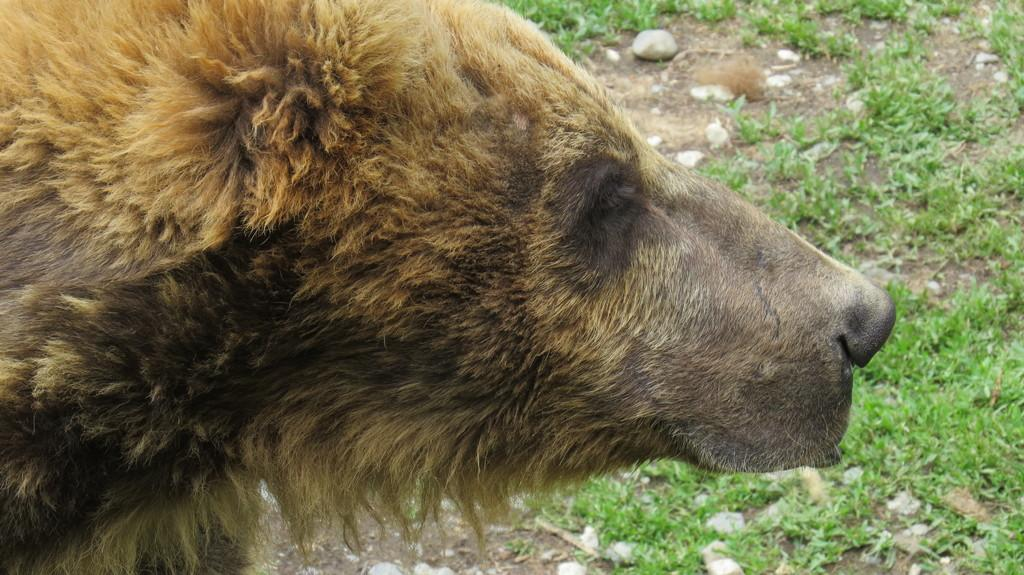What type of living creature can be seen in the picture? There is an animal in the picture. What can be seen beneath the animal's feet? The ground is visible in the picture. What type of vegetation is present on the ground? Grass is present on the ground. What else can be seen on the ground besides grass? Stones are present on the ground. What type of engine can be seen powering the animal in the image? There is no engine present in the image, and the animal is not depicted as being powered by any machinery. 